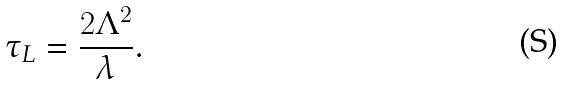Convert formula to latex. <formula><loc_0><loc_0><loc_500><loc_500>\tau _ { L } = \frac { 2 \Lambda ^ { 2 } } { \lambda } .</formula> 